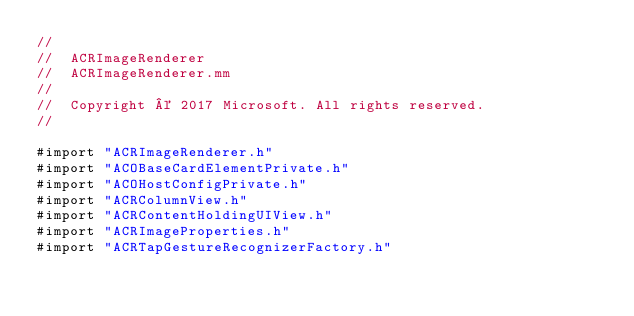<code> <loc_0><loc_0><loc_500><loc_500><_ObjectiveC_>//
//  ACRImageRenderer
//  ACRImageRenderer.mm
//
//  Copyright © 2017 Microsoft. All rights reserved.
//

#import "ACRImageRenderer.h"
#import "ACOBaseCardElementPrivate.h"
#import "ACOHostConfigPrivate.h"
#import "ACRColumnView.h"
#import "ACRContentHoldingUIView.h"
#import "ACRImageProperties.h"
#import "ACRTapGestureRecognizerFactory.h"</code> 